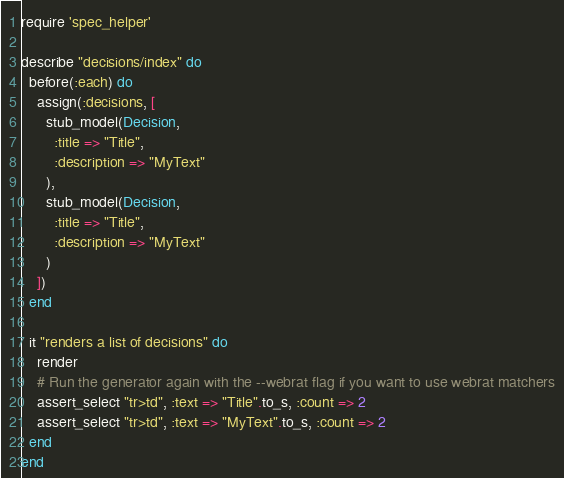<code> <loc_0><loc_0><loc_500><loc_500><_Ruby_>require 'spec_helper'

describe "decisions/index" do
  before(:each) do
    assign(:decisions, [
      stub_model(Decision,
        :title => "Title",
        :description => "MyText"
      ),
      stub_model(Decision,
        :title => "Title",
        :description => "MyText"
      )
    ])
  end

  it "renders a list of decisions" do
    render
    # Run the generator again with the --webrat flag if you want to use webrat matchers
    assert_select "tr>td", :text => "Title".to_s, :count => 2
    assert_select "tr>td", :text => "MyText".to_s, :count => 2
  end
end
</code> 